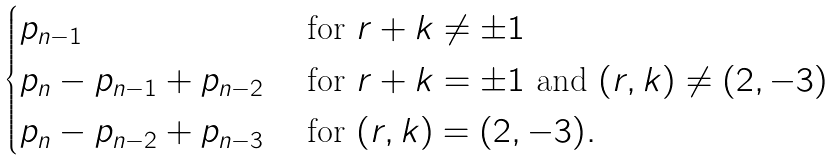<formula> <loc_0><loc_0><loc_500><loc_500>\begin{cases} p _ { n - 1 } & \text { for } r + k \neq \pm 1 \\ p _ { n } - p _ { n - 1 } + p _ { n - 2 } & \text { for } r + k = \pm 1 \text { and } ( r , k ) \neq ( 2 , - 3 ) \\ p _ { n } - p _ { n - 2 } + p _ { n - 3 } & \text { for } ( r , k ) = ( 2 , - 3 ) . \end{cases}</formula> 